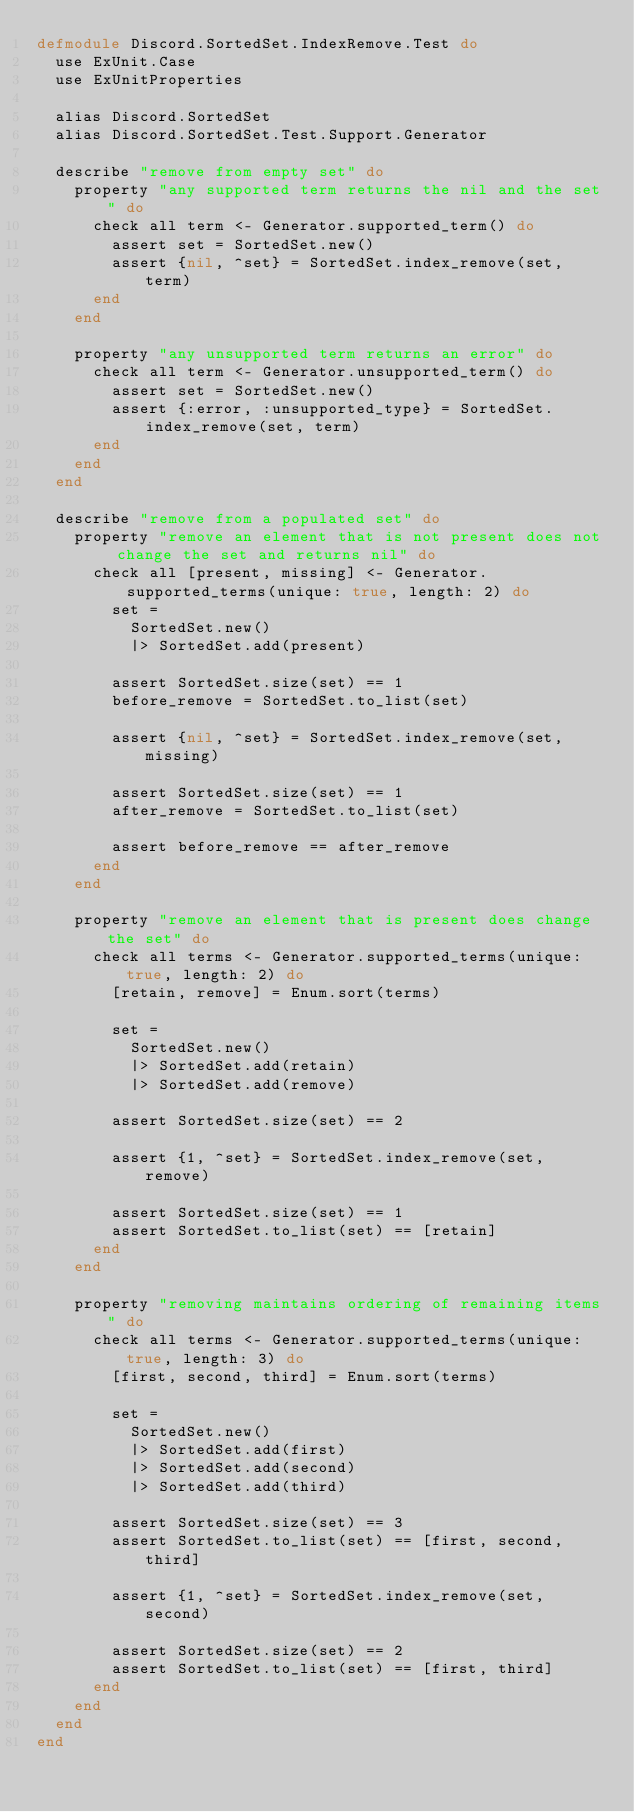Convert code to text. <code><loc_0><loc_0><loc_500><loc_500><_Elixir_>defmodule Discord.SortedSet.IndexRemove.Test do
  use ExUnit.Case
  use ExUnitProperties

  alias Discord.SortedSet
  alias Discord.SortedSet.Test.Support.Generator

  describe "remove from empty set" do
    property "any supported term returns the nil and the set" do
      check all term <- Generator.supported_term() do
        assert set = SortedSet.new()
        assert {nil, ^set} = SortedSet.index_remove(set, term)
      end
    end

    property "any unsupported term returns an error" do
      check all term <- Generator.unsupported_term() do
        assert set = SortedSet.new()
        assert {:error, :unsupported_type} = SortedSet.index_remove(set, term)
      end
    end
  end

  describe "remove from a populated set" do
    property "remove an element that is not present does not change the set and returns nil" do
      check all [present, missing] <- Generator.supported_terms(unique: true, length: 2) do
        set =
          SortedSet.new()
          |> SortedSet.add(present)

        assert SortedSet.size(set) == 1
        before_remove = SortedSet.to_list(set)

        assert {nil, ^set} = SortedSet.index_remove(set, missing)

        assert SortedSet.size(set) == 1
        after_remove = SortedSet.to_list(set)

        assert before_remove == after_remove
      end
    end

    property "remove an element that is present does change the set" do
      check all terms <- Generator.supported_terms(unique: true, length: 2) do
        [retain, remove] = Enum.sort(terms)

        set =
          SortedSet.new()
          |> SortedSet.add(retain)
          |> SortedSet.add(remove)

        assert SortedSet.size(set) == 2

        assert {1, ^set} = SortedSet.index_remove(set, remove)

        assert SortedSet.size(set) == 1
        assert SortedSet.to_list(set) == [retain]
      end
    end

    property "removing maintains ordering of remaining items" do
      check all terms <- Generator.supported_terms(unique: true, length: 3) do
        [first, second, third] = Enum.sort(terms)

        set =
          SortedSet.new()
          |> SortedSet.add(first)
          |> SortedSet.add(second)
          |> SortedSet.add(third)

        assert SortedSet.size(set) == 3
        assert SortedSet.to_list(set) == [first, second, third]

        assert {1, ^set} = SortedSet.index_remove(set, second)

        assert SortedSet.size(set) == 2
        assert SortedSet.to_list(set) == [first, third]
      end
    end
  end
end
</code> 